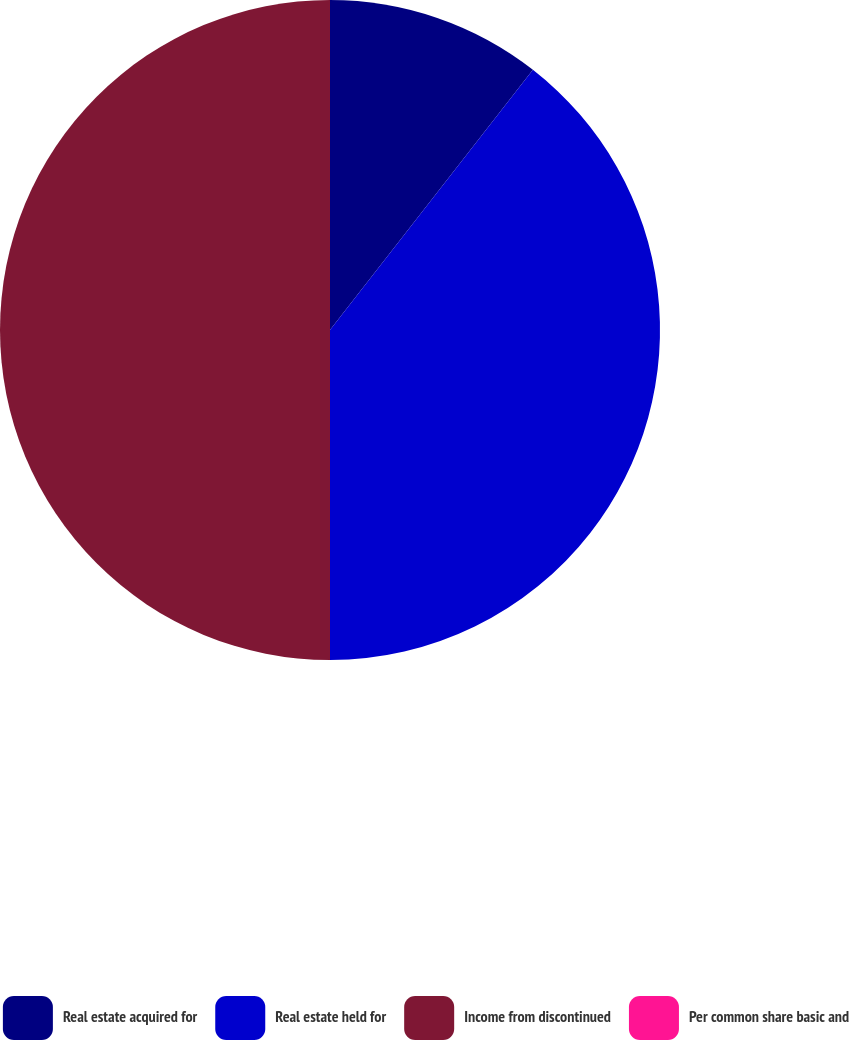Convert chart to OTSL. <chart><loc_0><loc_0><loc_500><loc_500><pie_chart><fcel>Real estate acquired for<fcel>Real estate held for<fcel>Income from discontinued<fcel>Per common share basic and<nl><fcel>10.54%<fcel>39.46%<fcel>50.0%<fcel>0.0%<nl></chart> 